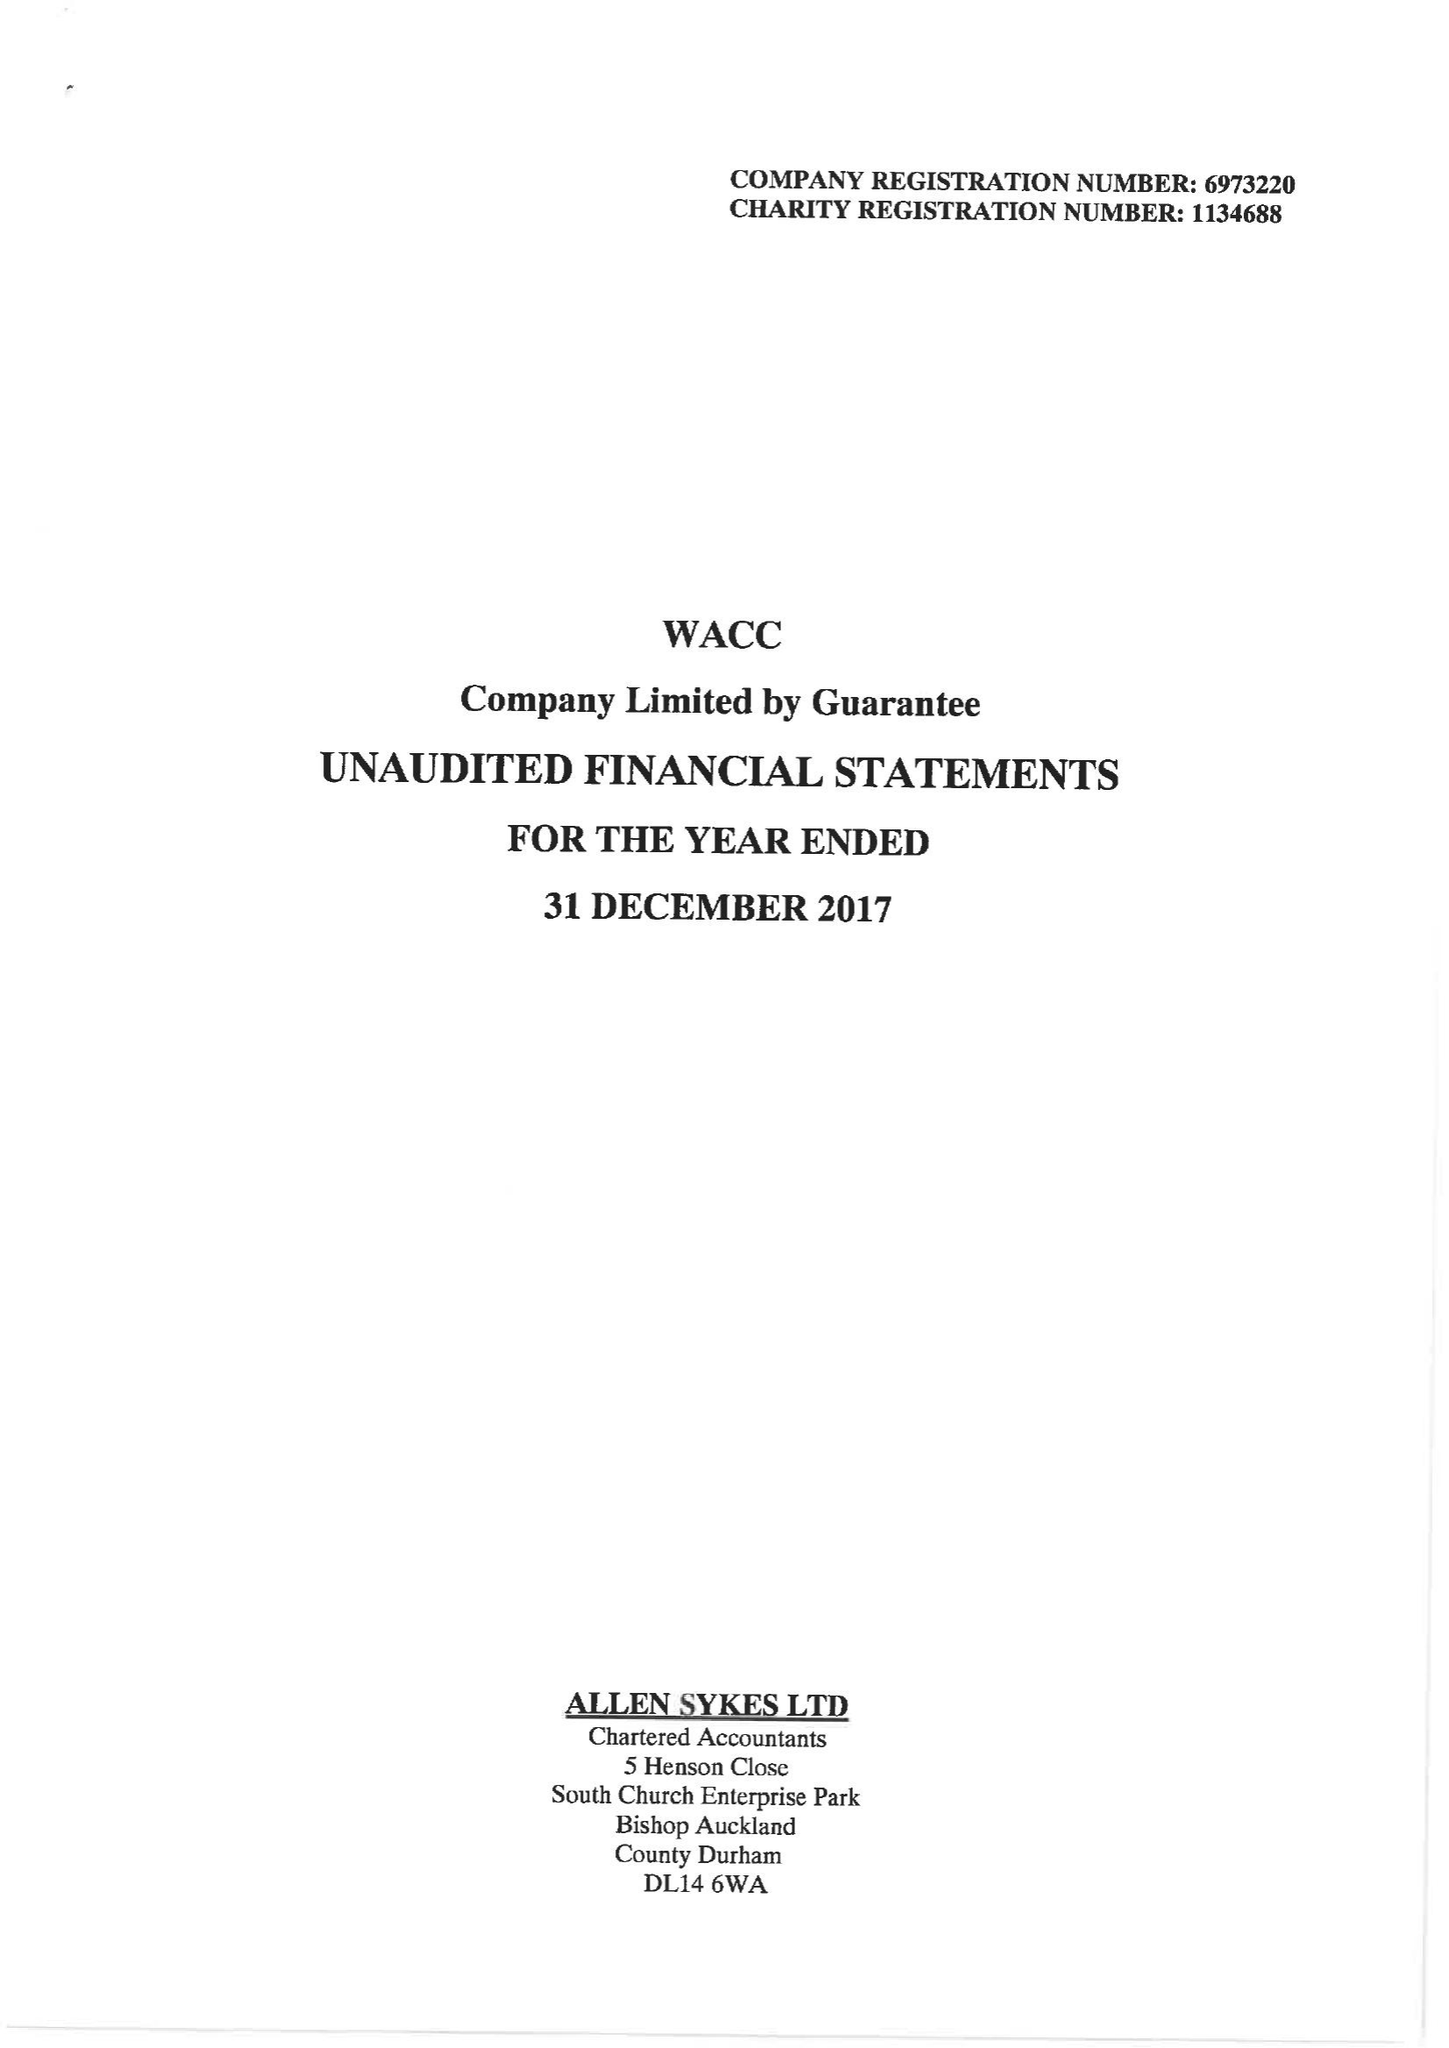What is the value for the report_date?
Answer the question using a single word or phrase. 2017-12-31 